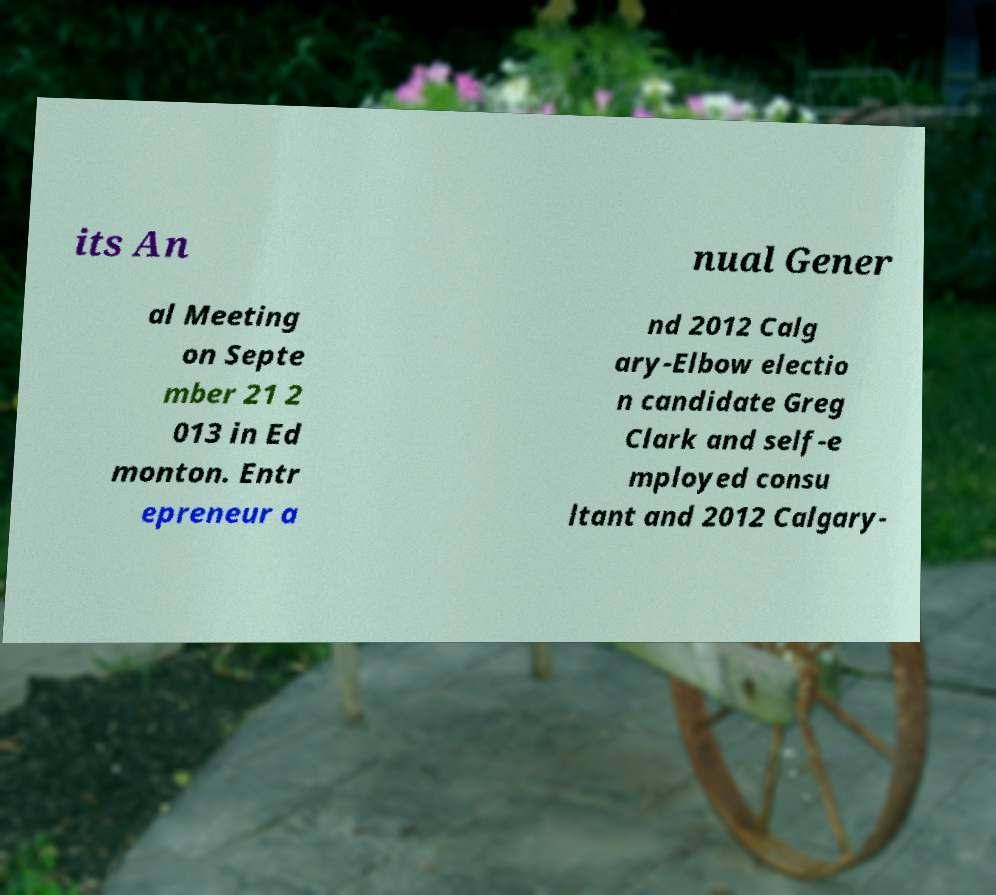Please identify and transcribe the text found in this image. its An nual Gener al Meeting on Septe mber 21 2 013 in Ed monton. Entr epreneur a nd 2012 Calg ary-Elbow electio n candidate Greg Clark and self-e mployed consu ltant and 2012 Calgary- 